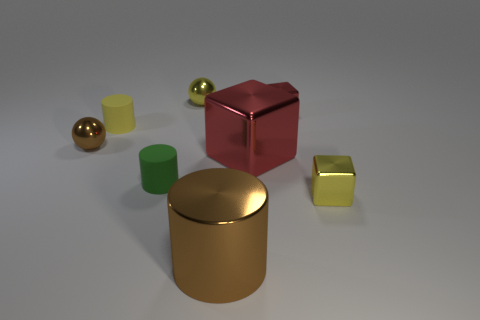Is there anything else that is made of the same material as the tiny green cylinder?
Offer a terse response. Yes. How many things are metallic things to the left of the yellow metallic sphere or brown balls?
Offer a terse response. 1. There is a yellow metallic sphere that is to the left of the small yellow block that is right of the tiny green cylinder; are there any green things that are to the right of it?
Offer a terse response. No. Are there the same number of red things and tiny yellow rubber cylinders?
Provide a succinct answer. No. How many tiny yellow shiny balls are there?
Make the answer very short. 1. What number of things are metal balls left of the yellow shiny ball or tiny objects that are right of the small yellow rubber cylinder?
Make the answer very short. 5. Is the size of the brown metal sphere that is on the left side of the green cylinder the same as the large red shiny cube?
Provide a succinct answer. No. There is a green matte thing that is the same shape as the yellow matte object; what size is it?
Give a very brief answer. Small. There is a block that is the same size as the brown cylinder; what is it made of?
Offer a very short reply. Metal. What is the material of the large object that is the same shape as the small green matte thing?
Your answer should be very brief. Metal. 